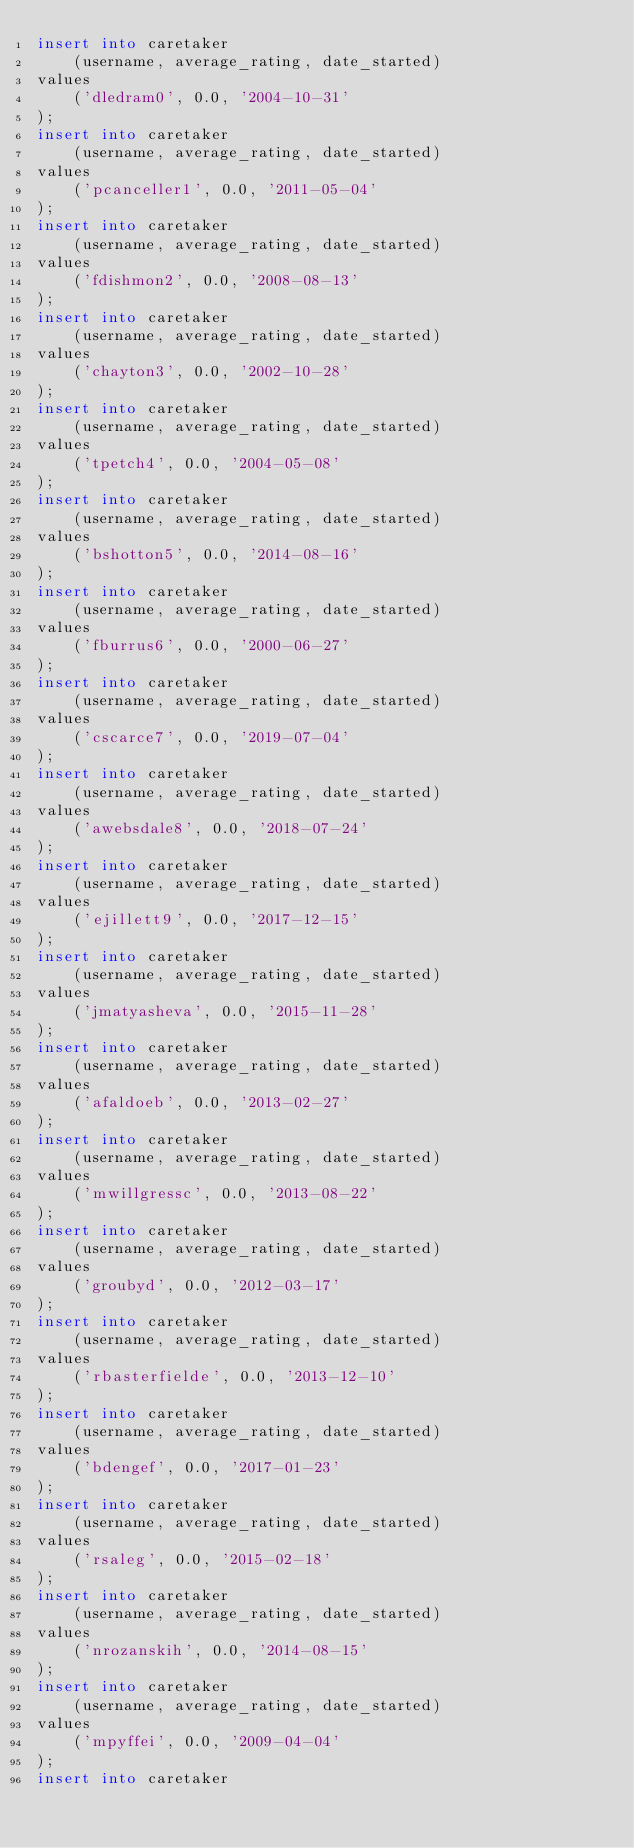<code> <loc_0><loc_0><loc_500><loc_500><_SQL_>insert into caretaker
    (username, average_rating, date_started)
values
    ('dledram0', 0.0, '2004-10-31'
);
insert into caretaker
    (username, average_rating, date_started)
values
    ('pcanceller1', 0.0, '2011-05-04'
);
insert into caretaker
    (username, average_rating, date_started)
values
    ('fdishmon2', 0.0, '2008-08-13'
);
insert into caretaker
    (username, average_rating, date_started)
values
    ('chayton3', 0.0, '2002-10-28'
);
insert into caretaker
    (username, average_rating, date_started)
values
    ('tpetch4', 0.0, '2004-05-08'
);
insert into caretaker
    (username, average_rating, date_started)
values
    ('bshotton5', 0.0, '2014-08-16'
);
insert into caretaker
    (username, average_rating, date_started)
values
    ('fburrus6', 0.0, '2000-06-27'
);
insert into caretaker
    (username, average_rating, date_started)
values
    ('cscarce7', 0.0, '2019-07-04'
);
insert into caretaker
    (username, average_rating, date_started)
values
    ('awebsdale8', 0.0, '2018-07-24'
);
insert into caretaker
    (username, average_rating, date_started)
values
    ('ejillett9', 0.0, '2017-12-15'
);
insert into caretaker
    (username, average_rating, date_started)
values
    ('jmatyasheva', 0.0, '2015-11-28'
);
insert into caretaker
    (username, average_rating, date_started)
values
    ('afaldoeb', 0.0, '2013-02-27'
);
insert into caretaker
    (username, average_rating, date_started)
values
    ('mwillgressc', 0.0, '2013-08-22'
);
insert into caretaker
    (username, average_rating, date_started)
values
    ('groubyd', 0.0, '2012-03-17'
);
insert into caretaker
    (username, average_rating, date_started)
values
    ('rbasterfielde', 0.0, '2013-12-10'
);
insert into caretaker
    (username, average_rating, date_started)
values
    ('bdengef', 0.0, '2017-01-23'
);
insert into caretaker
    (username, average_rating, date_started)
values
    ('rsaleg', 0.0, '2015-02-18'
);
insert into caretaker
    (username, average_rating, date_started)
values
    ('nrozanskih', 0.0, '2014-08-15'
);
insert into caretaker
    (username, average_rating, date_started)
values
    ('mpyffei', 0.0, '2009-04-04'
);
insert into caretaker</code> 